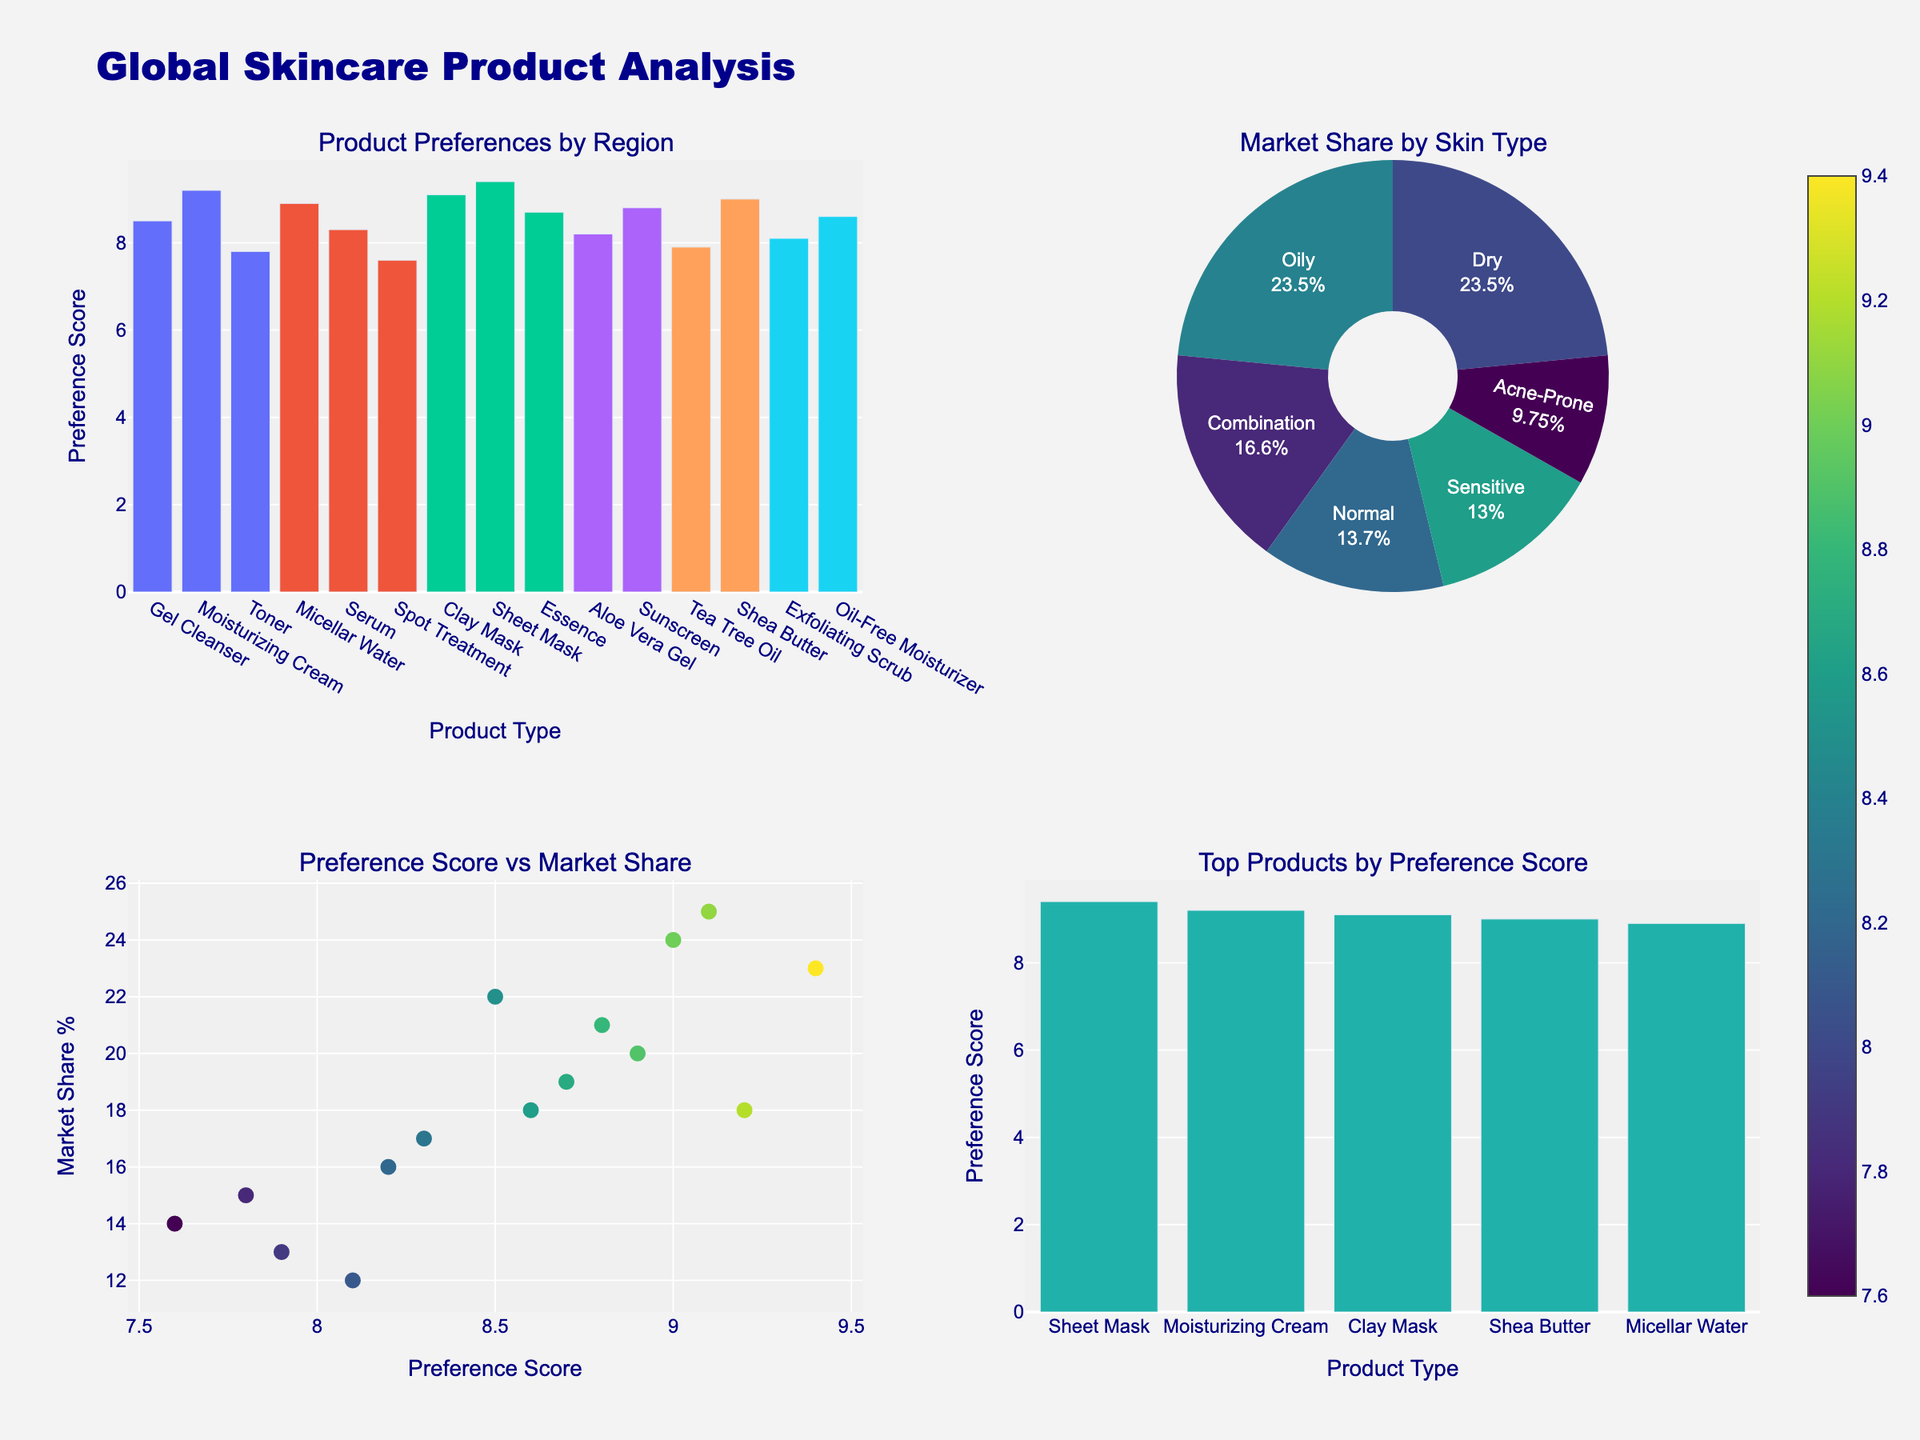What's the title of the chart? The title of the chart is clearly displayed at the top center of the figure.
Answer: School Violence Incidents by Type and Location What do the y-axes of the subplots represent? The y-axes of the subplots show the number of incidents, indicating how many incidents were recorded for each year.
Answer: Number of Incidents How many unique locations are represented in the plots? There are three location names indicated in the legend and represented by different colors in the figure.
Answer: Three What has been the trend in physical assault incidents in urban schools from 2013 to 2022? Looking at the plot for physical assaults, the lines for urban incidents show an upward trend from 2013 to 2022.
Answer: Increasing Which location has the highest number of incidents of weapon possession in 2019? By observing the subplot for weapon possession and comparing the values for different locations in 2019, urban schools have the highest incidents.
Answer: Urban How many total incidents of physical assault were reported in rural schools over all recorded years? Sum the number of incidents for rural locations listed in the subplot for physical assaults: 52 (2013) + 61 (2016) + 68 (2019) + 75 (2022).
Answer: 256 Compare the change in the number of weapon possession incidents from 2013 to 2022 in suburban and rural schools. Which increased more? Suburban went from 45 to 71, and rural went from 23 to 37. The change can be calculated as (71-45) for suburban, and (37-23) for rural. The change in suburban schools is larger.
Answer: Suburban What observation can be made about the trend in weapon possession incidents in rural schools? Observing the subplot for weapon possession, the number of incidents in rural schools shows a consistent upward trend across all years.
Answer: Increasing 